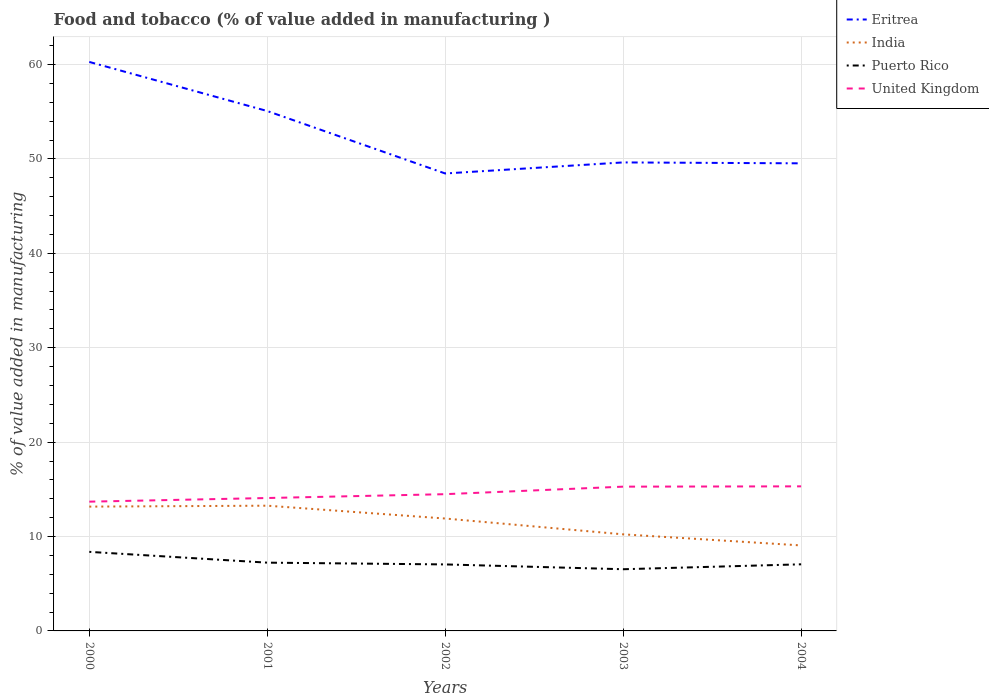Does the line corresponding to Puerto Rico intersect with the line corresponding to Eritrea?
Make the answer very short. No. Across all years, what is the maximum value added in manufacturing food and tobacco in Puerto Rico?
Your answer should be compact. 6.54. In which year was the value added in manufacturing food and tobacco in United Kingdom maximum?
Your answer should be very brief. 2000. What is the total value added in manufacturing food and tobacco in India in the graph?
Offer a very short reply. -0.1. What is the difference between the highest and the second highest value added in manufacturing food and tobacco in Puerto Rico?
Ensure brevity in your answer.  1.84. What is the difference between the highest and the lowest value added in manufacturing food and tobacco in Eritrea?
Offer a very short reply. 2. Is the value added in manufacturing food and tobacco in Eritrea strictly greater than the value added in manufacturing food and tobacco in Puerto Rico over the years?
Provide a succinct answer. No. Are the values on the major ticks of Y-axis written in scientific E-notation?
Keep it short and to the point. No. Does the graph contain any zero values?
Offer a very short reply. No. Does the graph contain grids?
Provide a succinct answer. Yes. Where does the legend appear in the graph?
Offer a terse response. Top right. How many legend labels are there?
Give a very brief answer. 4. How are the legend labels stacked?
Your response must be concise. Vertical. What is the title of the graph?
Your answer should be compact. Food and tobacco (% of value added in manufacturing ). Does "Guatemala" appear as one of the legend labels in the graph?
Make the answer very short. No. What is the label or title of the X-axis?
Give a very brief answer. Years. What is the label or title of the Y-axis?
Your answer should be very brief. % of value added in manufacturing. What is the % of value added in manufacturing of Eritrea in 2000?
Make the answer very short. 60.27. What is the % of value added in manufacturing in India in 2000?
Offer a very short reply. 13.17. What is the % of value added in manufacturing of Puerto Rico in 2000?
Provide a short and direct response. 8.38. What is the % of value added in manufacturing of United Kingdom in 2000?
Offer a terse response. 13.69. What is the % of value added in manufacturing in Eritrea in 2001?
Offer a terse response. 55.07. What is the % of value added in manufacturing in India in 2001?
Provide a short and direct response. 13.27. What is the % of value added in manufacturing in Puerto Rico in 2001?
Your answer should be compact. 7.23. What is the % of value added in manufacturing in United Kingdom in 2001?
Your answer should be compact. 14.08. What is the % of value added in manufacturing of Eritrea in 2002?
Ensure brevity in your answer.  48.46. What is the % of value added in manufacturing in India in 2002?
Ensure brevity in your answer.  11.91. What is the % of value added in manufacturing in Puerto Rico in 2002?
Your answer should be very brief. 7.04. What is the % of value added in manufacturing of United Kingdom in 2002?
Provide a succinct answer. 14.49. What is the % of value added in manufacturing in Eritrea in 2003?
Keep it short and to the point. 49.63. What is the % of value added in manufacturing of India in 2003?
Ensure brevity in your answer.  10.23. What is the % of value added in manufacturing of Puerto Rico in 2003?
Ensure brevity in your answer.  6.54. What is the % of value added in manufacturing in United Kingdom in 2003?
Your answer should be very brief. 15.28. What is the % of value added in manufacturing in Eritrea in 2004?
Your answer should be compact. 49.53. What is the % of value added in manufacturing in India in 2004?
Offer a very short reply. 9.06. What is the % of value added in manufacturing in Puerto Rico in 2004?
Your answer should be very brief. 7.06. What is the % of value added in manufacturing of United Kingdom in 2004?
Offer a terse response. 15.31. Across all years, what is the maximum % of value added in manufacturing of Eritrea?
Keep it short and to the point. 60.27. Across all years, what is the maximum % of value added in manufacturing in India?
Give a very brief answer. 13.27. Across all years, what is the maximum % of value added in manufacturing of Puerto Rico?
Your answer should be very brief. 8.38. Across all years, what is the maximum % of value added in manufacturing of United Kingdom?
Give a very brief answer. 15.31. Across all years, what is the minimum % of value added in manufacturing of Eritrea?
Provide a short and direct response. 48.46. Across all years, what is the minimum % of value added in manufacturing in India?
Give a very brief answer. 9.06. Across all years, what is the minimum % of value added in manufacturing in Puerto Rico?
Your response must be concise. 6.54. Across all years, what is the minimum % of value added in manufacturing of United Kingdom?
Provide a succinct answer. 13.69. What is the total % of value added in manufacturing of Eritrea in the graph?
Ensure brevity in your answer.  262.97. What is the total % of value added in manufacturing of India in the graph?
Provide a short and direct response. 57.63. What is the total % of value added in manufacturing in Puerto Rico in the graph?
Provide a succinct answer. 36.24. What is the total % of value added in manufacturing of United Kingdom in the graph?
Give a very brief answer. 72.86. What is the difference between the % of value added in manufacturing in India in 2000 and that in 2001?
Your answer should be compact. -0.1. What is the difference between the % of value added in manufacturing in Puerto Rico in 2000 and that in 2001?
Your response must be concise. 1.14. What is the difference between the % of value added in manufacturing in United Kingdom in 2000 and that in 2001?
Your response must be concise. -0.39. What is the difference between the % of value added in manufacturing of Eritrea in 2000 and that in 2002?
Give a very brief answer. 11.82. What is the difference between the % of value added in manufacturing of India in 2000 and that in 2002?
Make the answer very short. 1.26. What is the difference between the % of value added in manufacturing of Puerto Rico in 2000 and that in 2002?
Ensure brevity in your answer.  1.33. What is the difference between the % of value added in manufacturing in United Kingdom in 2000 and that in 2002?
Provide a succinct answer. -0.79. What is the difference between the % of value added in manufacturing of Eritrea in 2000 and that in 2003?
Offer a very short reply. 10.64. What is the difference between the % of value added in manufacturing of India in 2000 and that in 2003?
Make the answer very short. 2.94. What is the difference between the % of value added in manufacturing of Puerto Rico in 2000 and that in 2003?
Give a very brief answer. 1.84. What is the difference between the % of value added in manufacturing in United Kingdom in 2000 and that in 2003?
Ensure brevity in your answer.  -1.59. What is the difference between the % of value added in manufacturing of Eritrea in 2000 and that in 2004?
Make the answer very short. 10.74. What is the difference between the % of value added in manufacturing of India in 2000 and that in 2004?
Give a very brief answer. 4.11. What is the difference between the % of value added in manufacturing in Puerto Rico in 2000 and that in 2004?
Provide a succinct answer. 1.32. What is the difference between the % of value added in manufacturing of United Kingdom in 2000 and that in 2004?
Your response must be concise. -1.62. What is the difference between the % of value added in manufacturing in Eritrea in 2001 and that in 2002?
Offer a very short reply. 6.62. What is the difference between the % of value added in manufacturing in India in 2001 and that in 2002?
Your answer should be compact. 1.36. What is the difference between the % of value added in manufacturing in Puerto Rico in 2001 and that in 2002?
Provide a short and direct response. 0.19. What is the difference between the % of value added in manufacturing of United Kingdom in 2001 and that in 2002?
Ensure brevity in your answer.  -0.41. What is the difference between the % of value added in manufacturing in Eritrea in 2001 and that in 2003?
Your response must be concise. 5.44. What is the difference between the % of value added in manufacturing of India in 2001 and that in 2003?
Your answer should be compact. 3.04. What is the difference between the % of value added in manufacturing of Puerto Rico in 2001 and that in 2003?
Your answer should be very brief. 0.7. What is the difference between the % of value added in manufacturing in United Kingdom in 2001 and that in 2003?
Offer a terse response. -1.2. What is the difference between the % of value added in manufacturing of Eritrea in 2001 and that in 2004?
Provide a succinct answer. 5.54. What is the difference between the % of value added in manufacturing of India in 2001 and that in 2004?
Give a very brief answer. 4.21. What is the difference between the % of value added in manufacturing in Puerto Rico in 2001 and that in 2004?
Your answer should be compact. 0.18. What is the difference between the % of value added in manufacturing in United Kingdom in 2001 and that in 2004?
Offer a very short reply. -1.24. What is the difference between the % of value added in manufacturing in Eritrea in 2002 and that in 2003?
Your answer should be very brief. -1.17. What is the difference between the % of value added in manufacturing in India in 2002 and that in 2003?
Your response must be concise. 1.68. What is the difference between the % of value added in manufacturing of Puerto Rico in 2002 and that in 2003?
Offer a very short reply. 0.51. What is the difference between the % of value added in manufacturing of United Kingdom in 2002 and that in 2003?
Ensure brevity in your answer.  -0.8. What is the difference between the % of value added in manufacturing of Eritrea in 2002 and that in 2004?
Your response must be concise. -1.07. What is the difference between the % of value added in manufacturing in India in 2002 and that in 2004?
Your answer should be very brief. 2.85. What is the difference between the % of value added in manufacturing of Puerto Rico in 2002 and that in 2004?
Your answer should be compact. -0.01. What is the difference between the % of value added in manufacturing in United Kingdom in 2002 and that in 2004?
Offer a very short reply. -0.83. What is the difference between the % of value added in manufacturing in Eritrea in 2003 and that in 2004?
Provide a succinct answer. 0.1. What is the difference between the % of value added in manufacturing in India in 2003 and that in 2004?
Provide a succinct answer. 1.17. What is the difference between the % of value added in manufacturing in Puerto Rico in 2003 and that in 2004?
Make the answer very short. -0.52. What is the difference between the % of value added in manufacturing in United Kingdom in 2003 and that in 2004?
Offer a very short reply. -0.03. What is the difference between the % of value added in manufacturing of Eritrea in 2000 and the % of value added in manufacturing of India in 2001?
Keep it short and to the point. 47.01. What is the difference between the % of value added in manufacturing in Eritrea in 2000 and the % of value added in manufacturing in Puerto Rico in 2001?
Your answer should be very brief. 53.04. What is the difference between the % of value added in manufacturing of Eritrea in 2000 and the % of value added in manufacturing of United Kingdom in 2001?
Provide a short and direct response. 46.2. What is the difference between the % of value added in manufacturing in India in 2000 and the % of value added in manufacturing in Puerto Rico in 2001?
Your response must be concise. 5.94. What is the difference between the % of value added in manufacturing of India in 2000 and the % of value added in manufacturing of United Kingdom in 2001?
Your response must be concise. -0.91. What is the difference between the % of value added in manufacturing of Puerto Rico in 2000 and the % of value added in manufacturing of United Kingdom in 2001?
Give a very brief answer. -5.7. What is the difference between the % of value added in manufacturing of Eritrea in 2000 and the % of value added in manufacturing of India in 2002?
Provide a succinct answer. 48.37. What is the difference between the % of value added in manufacturing of Eritrea in 2000 and the % of value added in manufacturing of Puerto Rico in 2002?
Provide a short and direct response. 53.23. What is the difference between the % of value added in manufacturing of Eritrea in 2000 and the % of value added in manufacturing of United Kingdom in 2002?
Ensure brevity in your answer.  45.79. What is the difference between the % of value added in manufacturing in India in 2000 and the % of value added in manufacturing in Puerto Rico in 2002?
Provide a succinct answer. 6.12. What is the difference between the % of value added in manufacturing in India in 2000 and the % of value added in manufacturing in United Kingdom in 2002?
Offer a very short reply. -1.32. What is the difference between the % of value added in manufacturing in Puerto Rico in 2000 and the % of value added in manufacturing in United Kingdom in 2002?
Give a very brief answer. -6.11. What is the difference between the % of value added in manufacturing of Eritrea in 2000 and the % of value added in manufacturing of India in 2003?
Provide a succinct answer. 50.04. What is the difference between the % of value added in manufacturing in Eritrea in 2000 and the % of value added in manufacturing in Puerto Rico in 2003?
Make the answer very short. 53.74. What is the difference between the % of value added in manufacturing of Eritrea in 2000 and the % of value added in manufacturing of United Kingdom in 2003?
Make the answer very short. 44.99. What is the difference between the % of value added in manufacturing in India in 2000 and the % of value added in manufacturing in Puerto Rico in 2003?
Your response must be concise. 6.63. What is the difference between the % of value added in manufacturing in India in 2000 and the % of value added in manufacturing in United Kingdom in 2003?
Give a very brief answer. -2.11. What is the difference between the % of value added in manufacturing in Puerto Rico in 2000 and the % of value added in manufacturing in United Kingdom in 2003?
Offer a very short reply. -6.91. What is the difference between the % of value added in manufacturing in Eritrea in 2000 and the % of value added in manufacturing in India in 2004?
Provide a succinct answer. 51.22. What is the difference between the % of value added in manufacturing of Eritrea in 2000 and the % of value added in manufacturing of Puerto Rico in 2004?
Keep it short and to the point. 53.22. What is the difference between the % of value added in manufacturing of Eritrea in 2000 and the % of value added in manufacturing of United Kingdom in 2004?
Offer a very short reply. 44.96. What is the difference between the % of value added in manufacturing in India in 2000 and the % of value added in manufacturing in Puerto Rico in 2004?
Make the answer very short. 6.11. What is the difference between the % of value added in manufacturing of India in 2000 and the % of value added in manufacturing of United Kingdom in 2004?
Provide a succinct answer. -2.15. What is the difference between the % of value added in manufacturing in Puerto Rico in 2000 and the % of value added in manufacturing in United Kingdom in 2004?
Provide a short and direct response. -6.94. What is the difference between the % of value added in manufacturing of Eritrea in 2001 and the % of value added in manufacturing of India in 2002?
Your response must be concise. 43.17. What is the difference between the % of value added in manufacturing in Eritrea in 2001 and the % of value added in manufacturing in Puerto Rico in 2002?
Make the answer very short. 48.03. What is the difference between the % of value added in manufacturing in Eritrea in 2001 and the % of value added in manufacturing in United Kingdom in 2002?
Your answer should be compact. 40.59. What is the difference between the % of value added in manufacturing of India in 2001 and the % of value added in manufacturing of Puerto Rico in 2002?
Provide a short and direct response. 6.22. What is the difference between the % of value added in manufacturing in India in 2001 and the % of value added in manufacturing in United Kingdom in 2002?
Keep it short and to the point. -1.22. What is the difference between the % of value added in manufacturing of Puerto Rico in 2001 and the % of value added in manufacturing of United Kingdom in 2002?
Provide a short and direct response. -7.25. What is the difference between the % of value added in manufacturing of Eritrea in 2001 and the % of value added in manufacturing of India in 2003?
Make the answer very short. 44.84. What is the difference between the % of value added in manufacturing of Eritrea in 2001 and the % of value added in manufacturing of Puerto Rico in 2003?
Provide a succinct answer. 48.54. What is the difference between the % of value added in manufacturing in Eritrea in 2001 and the % of value added in manufacturing in United Kingdom in 2003?
Keep it short and to the point. 39.79. What is the difference between the % of value added in manufacturing of India in 2001 and the % of value added in manufacturing of Puerto Rico in 2003?
Ensure brevity in your answer.  6.73. What is the difference between the % of value added in manufacturing in India in 2001 and the % of value added in manufacturing in United Kingdom in 2003?
Provide a short and direct response. -2.02. What is the difference between the % of value added in manufacturing in Puerto Rico in 2001 and the % of value added in manufacturing in United Kingdom in 2003?
Keep it short and to the point. -8.05. What is the difference between the % of value added in manufacturing of Eritrea in 2001 and the % of value added in manufacturing of India in 2004?
Provide a short and direct response. 46.02. What is the difference between the % of value added in manufacturing in Eritrea in 2001 and the % of value added in manufacturing in Puerto Rico in 2004?
Keep it short and to the point. 48.02. What is the difference between the % of value added in manufacturing of Eritrea in 2001 and the % of value added in manufacturing of United Kingdom in 2004?
Give a very brief answer. 39.76. What is the difference between the % of value added in manufacturing of India in 2001 and the % of value added in manufacturing of Puerto Rico in 2004?
Keep it short and to the point. 6.21. What is the difference between the % of value added in manufacturing in India in 2001 and the % of value added in manufacturing in United Kingdom in 2004?
Your answer should be compact. -2.05. What is the difference between the % of value added in manufacturing in Puerto Rico in 2001 and the % of value added in manufacturing in United Kingdom in 2004?
Provide a short and direct response. -8.08. What is the difference between the % of value added in manufacturing of Eritrea in 2002 and the % of value added in manufacturing of India in 2003?
Make the answer very short. 38.23. What is the difference between the % of value added in manufacturing in Eritrea in 2002 and the % of value added in manufacturing in Puerto Rico in 2003?
Offer a terse response. 41.92. What is the difference between the % of value added in manufacturing of Eritrea in 2002 and the % of value added in manufacturing of United Kingdom in 2003?
Give a very brief answer. 33.18. What is the difference between the % of value added in manufacturing in India in 2002 and the % of value added in manufacturing in Puerto Rico in 2003?
Offer a terse response. 5.37. What is the difference between the % of value added in manufacturing of India in 2002 and the % of value added in manufacturing of United Kingdom in 2003?
Your response must be concise. -3.38. What is the difference between the % of value added in manufacturing of Puerto Rico in 2002 and the % of value added in manufacturing of United Kingdom in 2003?
Provide a succinct answer. -8.24. What is the difference between the % of value added in manufacturing in Eritrea in 2002 and the % of value added in manufacturing in India in 2004?
Offer a very short reply. 39.4. What is the difference between the % of value added in manufacturing in Eritrea in 2002 and the % of value added in manufacturing in Puerto Rico in 2004?
Make the answer very short. 41.4. What is the difference between the % of value added in manufacturing in Eritrea in 2002 and the % of value added in manufacturing in United Kingdom in 2004?
Your answer should be compact. 33.14. What is the difference between the % of value added in manufacturing of India in 2002 and the % of value added in manufacturing of Puerto Rico in 2004?
Offer a very short reply. 4.85. What is the difference between the % of value added in manufacturing of India in 2002 and the % of value added in manufacturing of United Kingdom in 2004?
Keep it short and to the point. -3.41. What is the difference between the % of value added in manufacturing in Puerto Rico in 2002 and the % of value added in manufacturing in United Kingdom in 2004?
Ensure brevity in your answer.  -8.27. What is the difference between the % of value added in manufacturing of Eritrea in 2003 and the % of value added in manufacturing of India in 2004?
Give a very brief answer. 40.57. What is the difference between the % of value added in manufacturing of Eritrea in 2003 and the % of value added in manufacturing of Puerto Rico in 2004?
Offer a very short reply. 42.57. What is the difference between the % of value added in manufacturing in Eritrea in 2003 and the % of value added in manufacturing in United Kingdom in 2004?
Your answer should be compact. 34.32. What is the difference between the % of value added in manufacturing in India in 2003 and the % of value added in manufacturing in Puerto Rico in 2004?
Ensure brevity in your answer.  3.17. What is the difference between the % of value added in manufacturing of India in 2003 and the % of value added in manufacturing of United Kingdom in 2004?
Ensure brevity in your answer.  -5.08. What is the difference between the % of value added in manufacturing in Puerto Rico in 2003 and the % of value added in manufacturing in United Kingdom in 2004?
Your answer should be very brief. -8.78. What is the average % of value added in manufacturing of Eritrea per year?
Provide a succinct answer. 52.59. What is the average % of value added in manufacturing in India per year?
Offer a very short reply. 11.53. What is the average % of value added in manufacturing of Puerto Rico per year?
Give a very brief answer. 7.25. What is the average % of value added in manufacturing of United Kingdom per year?
Provide a short and direct response. 14.57. In the year 2000, what is the difference between the % of value added in manufacturing of Eritrea and % of value added in manufacturing of India?
Give a very brief answer. 47.11. In the year 2000, what is the difference between the % of value added in manufacturing of Eritrea and % of value added in manufacturing of Puerto Rico?
Make the answer very short. 51.9. In the year 2000, what is the difference between the % of value added in manufacturing of Eritrea and % of value added in manufacturing of United Kingdom?
Your answer should be very brief. 46.58. In the year 2000, what is the difference between the % of value added in manufacturing of India and % of value added in manufacturing of Puerto Rico?
Make the answer very short. 4.79. In the year 2000, what is the difference between the % of value added in manufacturing in India and % of value added in manufacturing in United Kingdom?
Provide a succinct answer. -0.52. In the year 2000, what is the difference between the % of value added in manufacturing in Puerto Rico and % of value added in manufacturing in United Kingdom?
Your answer should be very brief. -5.32. In the year 2001, what is the difference between the % of value added in manufacturing of Eritrea and % of value added in manufacturing of India?
Provide a short and direct response. 41.81. In the year 2001, what is the difference between the % of value added in manufacturing of Eritrea and % of value added in manufacturing of Puerto Rico?
Offer a terse response. 47.84. In the year 2001, what is the difference between the % of value added in manufacturing of Eritrea and % of value added in manufacturing of United Kingdom?
Offer a terse response. 41. In the year 2001, what is the difference between the % of value added in manufacturing of India and % of value added in manufacturing of Puerto Rico?
Give a very brief answer. 6.03. In the year 2001, what is the difference between the % of value added in manufacturing in India and % of value added in manufacturing in United Kingdom?
Offer a terse response. -0.81. In the year 2001, what is the difference between the % of value added in manufacturing in Puerto Rico and % of value added in manufacturing in United Kingdom?
Provide a short and direct response. -6.85. In the year 2002, what is the difference between the % of value added in manufacturing of Eritrea and % of value added in manufacturing of India?
Ensure brevity in your answer.  36.55. In the year 2002, what is the difference between the % of value added in manufacturing of Eritrea and % of value added in manufacturing of Puerto Rico?
Your answer should be very brief. 41.41. In the year 2002, what is the difference between the % of value added in manufacturing of Eritrea and % of value added in manufacturing of United Kingdom?
Provide a succinct answer. 33.97. In the year 2002, what is the difference between the % of value added in manufacturing in India and % of value added in manufacturing in Puerto Rico?
Give a very brief answer. 4.86. In the year 2002, what is the difference between the % of value added in manufacturing of India and % of value added in manufacturing of United Kingdom?
Keep it short and to the point. -2.58. In the year 2002, what is the difference between the % of value added in manufacturing in Puerto Rico and % of value added in manufacturing in United Kingdom?
Give a very brief answer. -7.44. In the year 2003, what is the difference between the % of value added in manufacturing in Eritrea and % of value added in manufacturing in India?
Offer a terse response. 39.4. In the year 2003, what is the difference between the % of value added in manufacturing in Eritrea and % of value added in manufacturing in Puerto Rico?
Make the answer very short. 43.1. In the year 2003, what is the difference between the % of value added in manufacturing in Eritrea and % of value added in manufacturing in United Kingdom?
Ensure brevity in your answer.  34.35. In the year 2003, what is the difference between the % of value added in manufacturing in India and % of value added in manufacturing in Puerto Rico?
Make the answer very short. 3.7. In the year 2003, what is the difference between the % of value added in manufacturing in India and % of value added in manufacturing in United Kingdom?
Offer a very short reply. -5.05. In the year 2003, what is the difference between the % of value added in manufacturing of Puerto Rico and % of value added in manufacturing of United Kingdom?
Your response must be concise. -8.75. In the year 2004, what is the difference between the % of value added in manufacturing of Eritrea and % of value added in manufacturing of India?
Keep it short and to the point. 40.48. In the year 2004, what is the difference between the % of value added in manufacturing in Eritrea and % of value added in manufacturing in Puerto Rico?
Your answer should be compact. 42.48. In the year 2004, what is the difference between the % of value added in manufacturing of Eritrea and % of value added in manufacturing of United Kingdom?
Your response must be concise. 34.22. In the year 2004, what is the difference between the % of value added in manufacturing in India and % of value added in manufacturing in Puerto Rico?
Ensure brevity in your answer.  2. In the year 2004, what is the difference between the % of value added in manufacturing of India and % of value added in manufacturing of United Kingdom?
Your answer should be very brief. -6.26. In the year 2004, what is the difference between the % of value added in manufacturing in Puerto Rico and % of value added in manufacturing in United Kingdom?
Your answer should be very brief. -8.26. What is the ratio of the % of value added in manufacturing of Eritrea in 2000 to that in 2001?
Provide a succinct answer. 1.09. What is the ratio of the % of value added in manufacturing of India in 2000 to that in 2001?
Make the answer very short. 0.99. What is the ratio of the % of value added in manufacturing in Puerto Rico in 2000 to that in 2001?
Offer a terse response. 1.16. What is the ratio of the % of value added in manufacturing in United Kingdom in 2000 to that in 2001?
Offer a very short reply. 0.97. What is the ratio of the % of value added in manufacturing of Eritrea in 2000 to that in 2002?
Your answer should be very brief. 1.24. What is the ratio of the % of value added in manufacturing in India in 2000 to that in 2002?
Ensure brevity in your answer.  1.11. What is the ratio of the % of value added in manufacturing of Puerto Rico in 2000 to that in 2002?
Provide a succinct answer. 1.19. What is the ratio of the % of value added in manufacturing in United Kingdom in 2000 to that in 2002?
Give a very brief answer. 0.95. What is the ratio of the % of value added in manufacturing of Eritrea in 2000 to that in 2003?
Your answer should be very brief. 1.21. What is the ratio of the % of value added in manufacturing in India in 2000 to that in 2003?
Keep it short and to the point. 1.29. What is the ratio of the % of value added in manufacturing in Puerto Rico in 2000 to that in 2003?
Give a very brief answer. 1.28. What is the ratio of the % of value added in manufacturing of United Kingdom in 2000 to that in 2003?
Ensure brevity in your answer.  0.9. What is the ratio of the % of value added in manufacturing in Eritrea in 2000 to that in 2004?
Offer a terse response. 1.22. What is the ratio of the % of value added in manufacturing in India in 2000 to that in 2004?
Your answer should be very brief. 1.45. What is the ratio of the % of value added in manufacturing of Puerto Rico in 2000 to that in 2004?
Provide a short and direct response. 1.19. What is the ratio of the % of value added in manufacturing of United Kingdom in 2000 to that in 2004?
Ensure brevity in your answer.  0.89. What is the ratio of the % of value added in manufacturing of Eritrea in 2001 to that in 2002?
Provide a succinct answer. 1.14. What is the ratio of the % of value added in manufacturing of India in 2001 to that in 2002?
Offer a terse response. 1.11. What is the ratio of the % of value added in manufacturing of Puerto Rico in 2001 to that in 2002?
Give a very brief answer. 1.03. What is the ratio of the % of value added in manufacturing in United Kingdom in 2001 to that in 2002?
Your response must be concise. 0.97. What is the ratio of the % of value added in manufacturing of Eritrea in 2001 to that in 2003?
Offer a very short reply. 1.11. What is the ratio of the % of value added in manufacturing of India in 2001 to that in 2003?
Ensure brevity in your answer.  1.3. What is the ratio of the % of value added in manufacturing in Puerto Rico in 2001 to that in 2003?
Provide a short and direct response. 1.11. What is the ratio of the % of value added in manufacturing in United Kingdom in 2001 to that in 2003?
Make the answer very short. 0.92. What is the ratio of the % of value added in manufacturing in Eritrea in 2001 to that in 2004?
Offer a terse response. 1.11. What is the ratio of the % of value added in manufacturing in India in 2001 to that in 2004?
Keep it short and to the point. 1.46. What is the ratio of the % of value added in manufacturing in Puerto Rico in 2001 to that in 2004?
Your answer should be very brief. 1.02. What is the ratio of the % of value added in manufacturing of United Kingdom in 2001 to that in 2004?
Keep it short and to the point. 0.92. What is the ratio of the % of value added in manufacturing of Eritrea in 2002 to that in 2003?
Offer a terse response. 0.98. What is the ratio of the % of value added in manufacturing of India in 2002 to that in 2003?
Ensure brevity in your answer.  1.16. What is the ratio of the % of value added in manufacturing in Puerto Rico in 2002 to that in 2003?
Offer a terse response. 1.08. What is the ratio of the % of value added in manufacturing of United Kingdom in 2002 to that in 2003?
Ensure brevity in your answer.  0.95. What is the ratio of the % of value added in manufacturing of Eritrea in 2002 to that in 2004?
Offer a terse response. 0.98. What is the ratio of the % of value added in manufacturing in India in 2002 to that in 2004?
Your answer should be very brief. 1.31. What is the ratio of the % of value added in manufacturing in Puerto Rico in 2002 to that in 2004?
Offer a very short reply. 1. What is the ratio of the % of value added in manufacturing of United Kingdom in 2002 to that in 2004?
Keep it short and to the point. 0.95. What is the ratio of the % of value added in manufacturing in Eritrea in 2003 to that in 2004?
Provide a short and direct response. 1. What is the ratio of the % of value added in manufacturing in India in 2003 to that in 2004?
Provide a succinct answer. 1.13. What is the ratio of the % of value added in manufacturing of Puerto Rico in 2003 to that in 2004?
Your answer should be very brief. 0.93. What is the ratio of the % of value added in manufacturing in United Kingdom in 2003 to that in 2004?
Make the answer very short. 1. What is the difference between the highest and the second highest % of value added in manufacturing in India?
Your answer should be very brief. 0.1. What is the difference between the highest and the second highest % of value added in manufacturing of Puerto Rico?
Offer a terse response. 1.14. What is the difference between the highest and the second highest % of value added in manufacturing of United Kingdom?
Ensure brevity in your answer.  0.03. What is the difference between the highest and the lowest % of value added in manufacturing of Eritrea?
Your answer should be very brief. 11.82. What is the difference between the highest and the lowest % of value added in manufacturing in India?
Your answer should be compact. 4.21. What is the difference between the highest and the lowest % of value added in manufacturing of Puerto Rico?
Your answer should be compact. 1.84. What is the difference between the highest and the lowest % of value added in manufacturing of United Kingdom?
Make the answer very short. 1.62. 